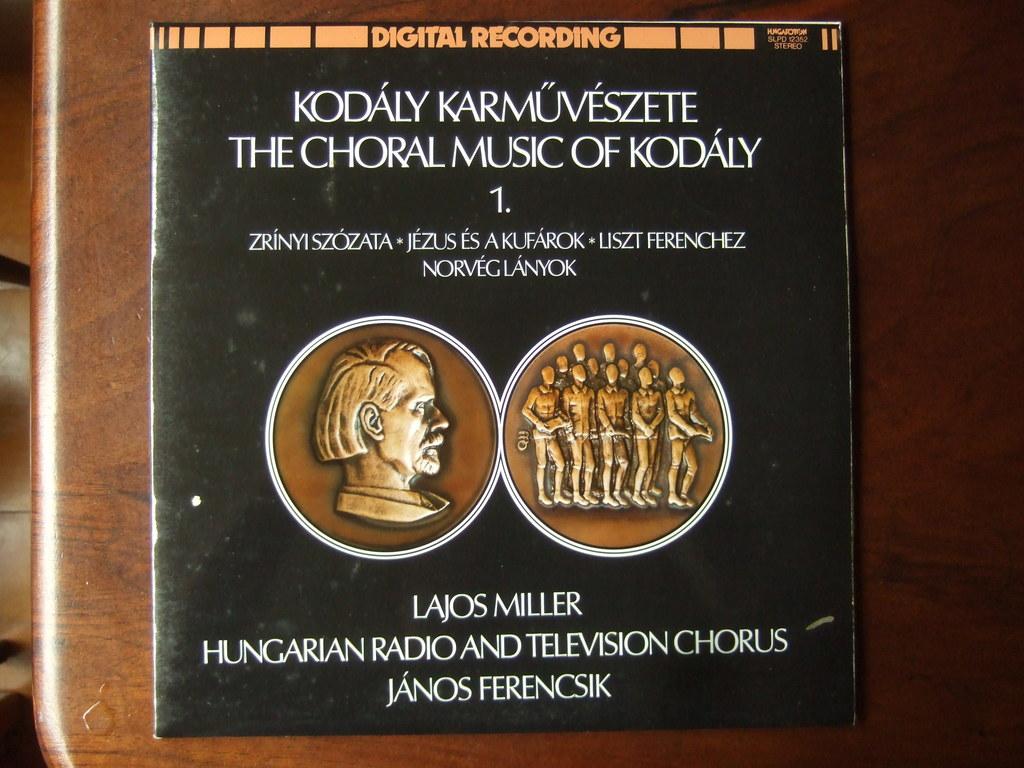Is this the chorla music of kodaly?
Your answer should be very brief. Yes. Is it music award?
Provide a succinct answer. No. 